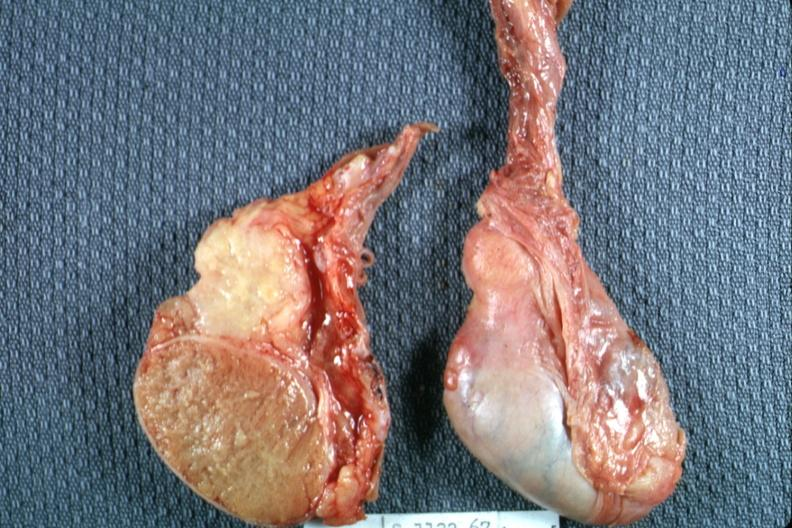what is present?
Answer the question using a single word or phrase. Epididymis 